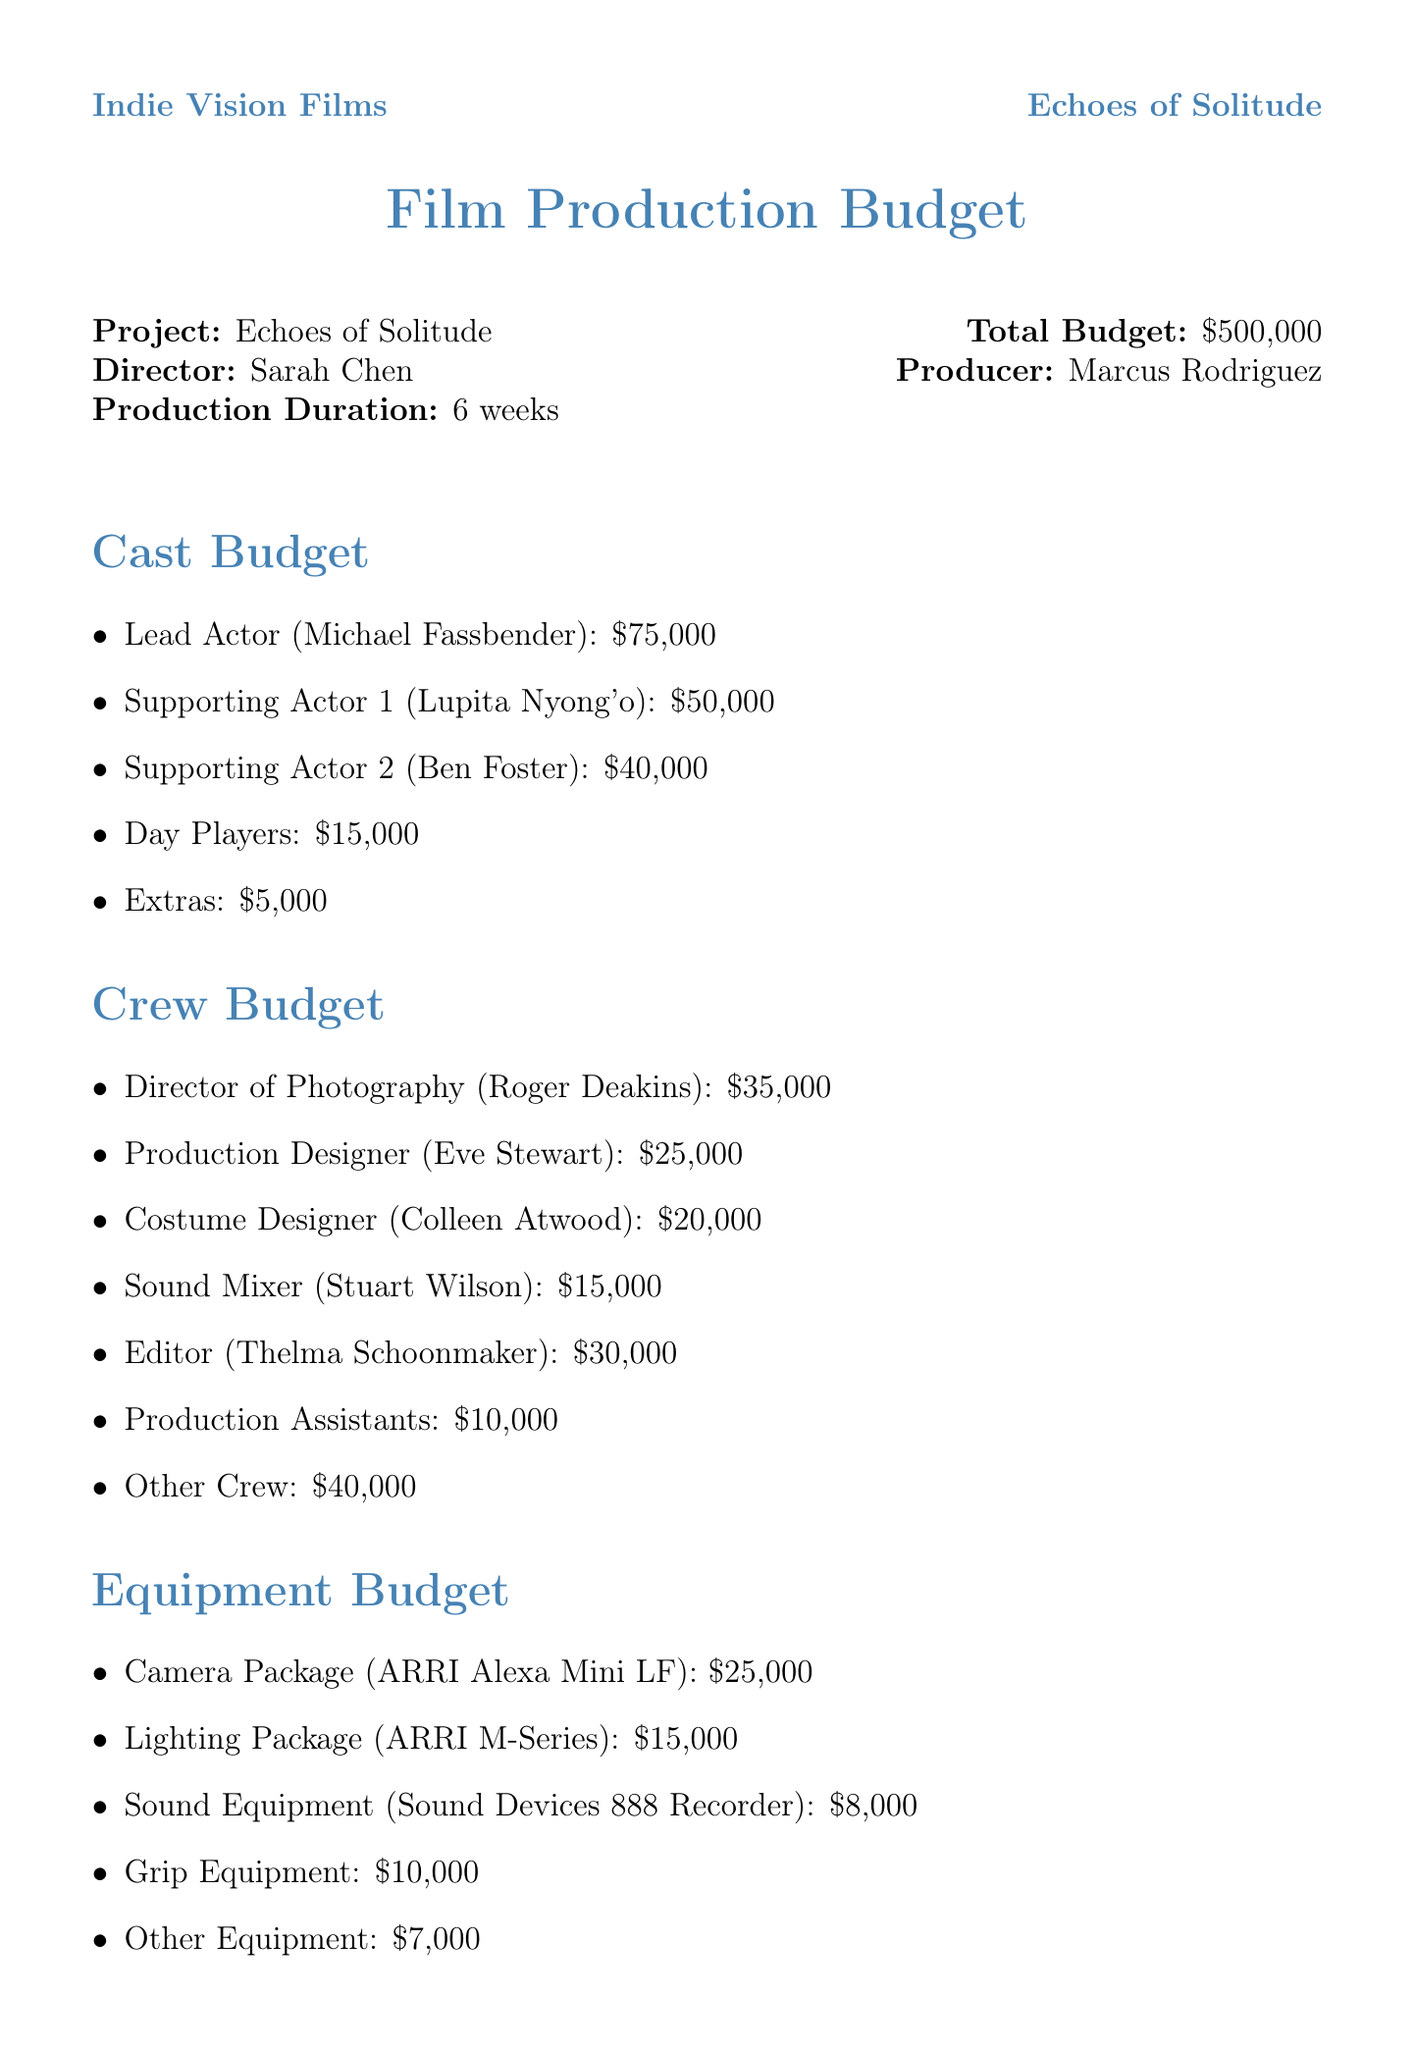What is the total budget for the film? The total budget is stated clearly in the document as the overall figure meant for production, which is $500,000.
Answer: $500,000 Who is the director of the film? The director's name appears prominently in the document under the project details, specifically listed as Sarah Chen.
Answer: Sarah Chen What is the fee for the lead actor? The document specifies the fee allocated for the lead actor, which is detailed in the cast budget section as $75,000.
Answer: $75,000 How much is allocated for post-production sound mixing and design? The post-production budget outlines that sound mixing and design has a cost of $12,000 listed specifically.
Answer: $12,000 What is the cost of permits and fees for locations? The location budget contains a line item specifically for permits and fees, stating that the cost is $5,000.
Answer: $5,000 How many weeks is the production scheduled to last? The production duration is mentioned explicitly in the document, indicating that it lasts for 6 weeks.
Answer: 6 weeks Who is responsible for the costume design? The document lists the costume designer clearly in the crew budget section, naming Colleen Atwood.
Answer: Colleen Atwood What is the cost of marketing and PR? Marketing and public relations expenses are indicated in the document as a separate budget item totaling $30,000.
Answer: $30,000 How much is set aside for catering expenses? Catering is mentioned in the miscellaneous expenses, with the total amount specified as $20,000.
Answer: $20,000 